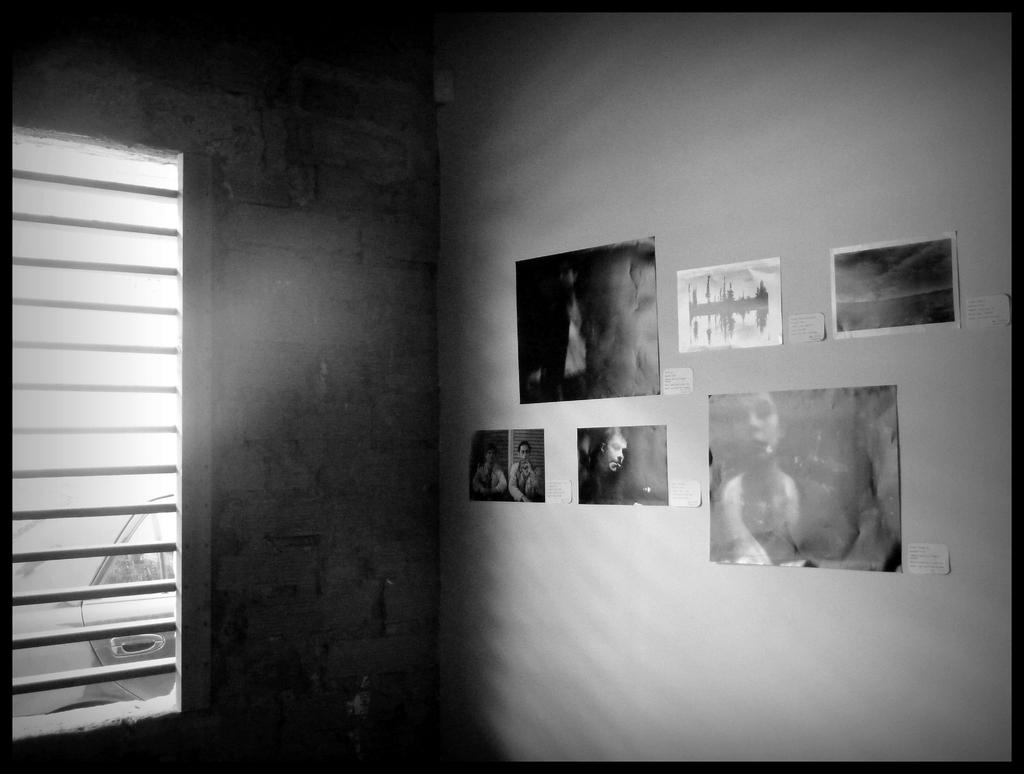What is the color scheme of the image? The image is black and white. What can be seen attached to the wall in the image? There are posts attached to the wall in the image. Where is the window located in the image? The window is on the left side of the image. What is visible through the window in the image? A vehicle is visible through the window. Can you see any yaks grazing in the image? There are no yaks present in the image. What type of game is being played in the image? There is no game being played in the image. 